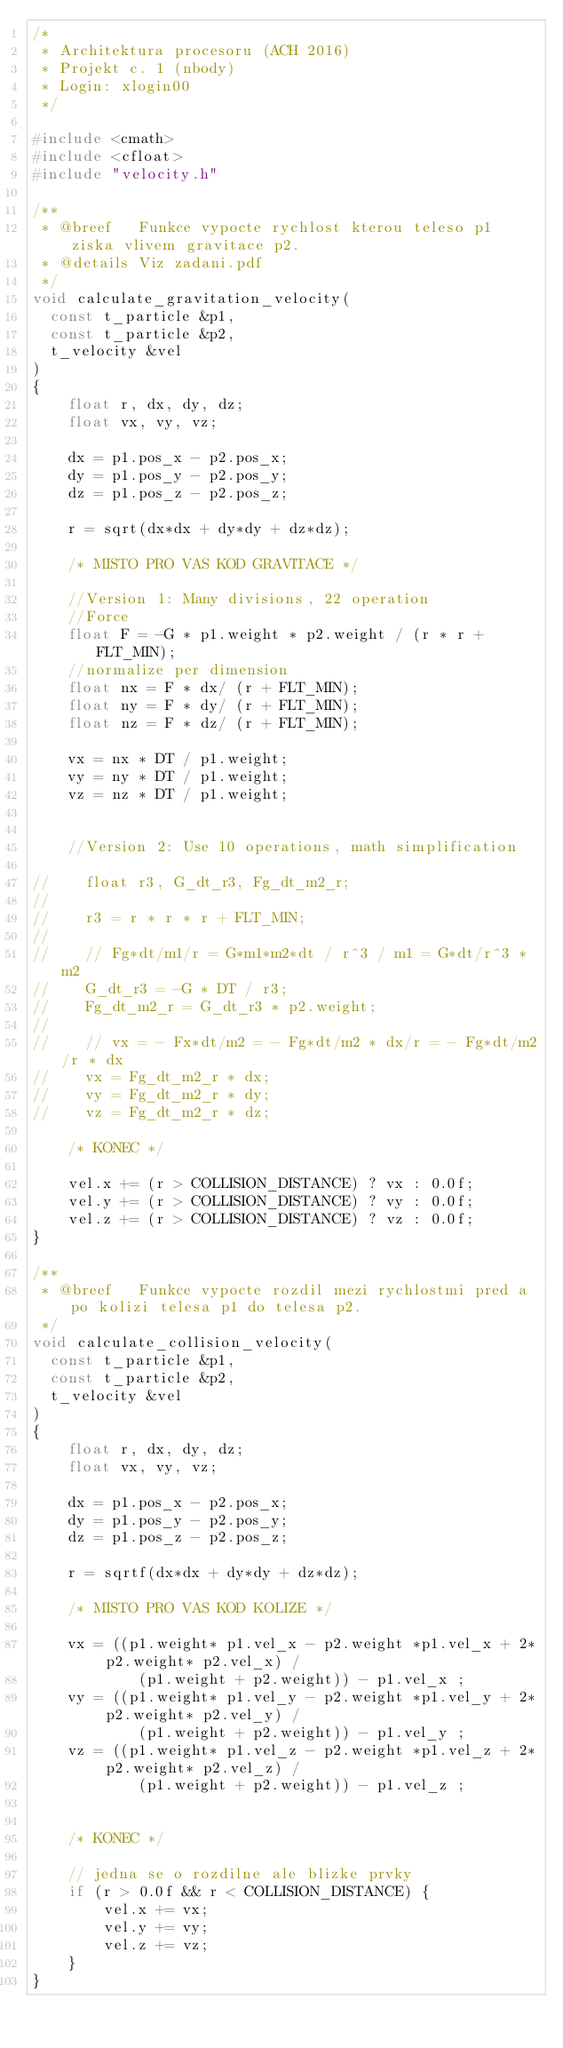<code> <loc_0><loc_0><loc_500><loc_500><_C++_>/*
 * Architektura procesoru (ACH 2016)
 * Projekt c. 1 (nbody)
 * Login: xlogin00
 */

#include <cmath>
#include <cfloat>
#include "velocity.h"

/**
 * @breef   Funkce vypocte rychlost kterou teleso p1 ziska vlivem gravitace p2.
 * @details Viz zadani.pdf
 */
void calculate_gravitation_velocity(
  const t_particle &p1,
  const t_particle &p2,
  t_velocity &vel
)
{
    float r, dx, dy, dz;
    float vx, vy, vz;

    dx = p1.pos_x - p2.pos_x;
    dy = p1.pos_y - p2.pos_y;
    dz = p1.pos_z - p2.pos_z;

    r = sqrt(dx*dx + dy*dy + dz*dz);

    /* MISTO PRO VAS KOD GRAVITACE */

    //Version 1: Many divisions, 22 operation
    //Force
    float F = -G * p1.weight * p2.weight / (r * r + FLT_MIN);
    //normalize per dimension
    float nx = F * dx/ (r + FLT_MIN);
    float ny = F * dy/ (r + FLT_MIN);
    float nz = F * dz/ (r + FLT_MIN);

    vx = nx * DT / p1.weight;
    vy = ny * DT / p1.weight;
    vz = nz * DT / p1.weight;


    //Version 2: Use 10 operations, math simplification

//    float r3, G_dt_r3, Fg_dt_m2_r;
//
//    r3 = r * r * r + FLT_MIN;
//
//    // Fg*dt/m1/r = G*m1*m2*dt / r^3 / m1 = G*dt/r^3 * m2
//    G_dt_r3 = -G * DT / r3;
//    Fg_dt_m2_r = G_dt_r3 * p2.weight;
//
//    // vx = - Fx*dt/m2 = - Fg*dt/m2 * dx/r = - Fg*dt/m2/r * dx
//    vx = Fg_dt_m2_r * dx;
//    vy = Fg_dt_m2_r * dy;
//    vz = Fg_dt_m2_r * dz;

    /* KONEC */

    vel.x += (r > COLLISION_DISTANCE) ? vx : 0.0f;
    vel.y += (r > COLLISION_DISTANCE) ? vy : 0.0f;
    vel.z += (r > COLLISION_DISTANCE) ? vz : 0.0f;
}

/**
 * @breef   Funkce vypocte rozdil mezi rychlostmi pred a po kolizi telesa p1 do telesa p2.
 */
void calculate_collision_velocity(
  const t_particle &p1,
  const t_particle &p2,
  t_velocity &vel
)
{
    float r, dx, dy, dz;
    float vx, vy, vz;

    dx = p1.pos_x - p2.pos_x;
    dy = p1.pos_y - p2.pos_y;
    dz = p1.pos_z - p2.pos_z;

    r = sqrtf(dx*dx + dy*dy + dz*dz);

    /* MISTO PRO VAS KOD KOLIZE */

    vx = ((p1.weight* p1.vel_x - p2.weight *p1.vel_x + 2* p2.weight* p2.vel_x) /
            (p1.weight + p2.weight)) - p1.vel_x ;
    vy = ((p1.weight* p1.vel_y - p2.weight *p1.vel_y + 2* p2.weight* p2.vel_y) /
            (p1.weight + p2.weight)) - p1.vel_y ;
    vz = ((p1.weight* p1.vel_z - p2.weight *p1.vel_z + 2* p2.weight* p2.vel_z) /
            (p1.weight + p2.weight)) - p1.vel_z ;


    /* KONEC */

    // jedna se o rozdilne ale blizke prvky
    if (r > 0.0f && r < COLLISION_DISTANCE) {
        vel.x += vx;
        vel.y += vy;
        vel.z += vz;
    }
}
</code> 